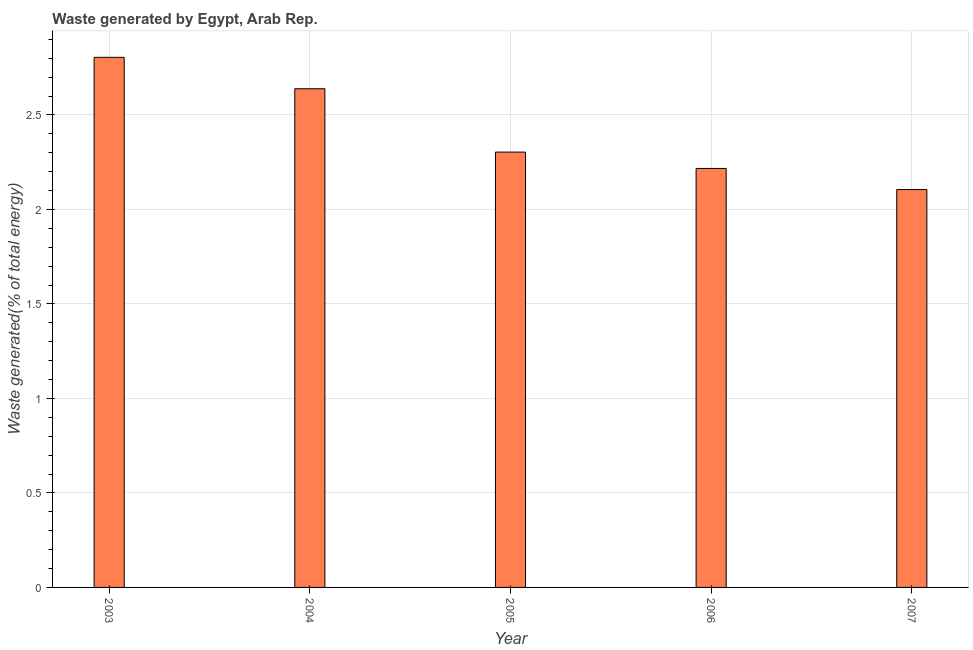Does the graph contain any zero values?
Your answer should be compact. No. Does the graph contain grids?
Provide a short and direct response. Yes. What is the title of the graph?
Provide a short and direct response. Waste generated by Egypt, Arab Rep. What is the label or title of the X-axis?
Make the answer very short. Year. What is the label or title of the Y-axis?
Keep it short and to the point. Waste generated(% of total energy). What is the amount of waste generated in 2004?
Provide a succinct answer. 2.64. Across all years, what is the maximum amount of waste generated?
Give a very brief answer. 2.8. Across all years, what is the minimum amount of waste generated?
Keep it short and to the point. 2.11. In which year was the amount of waste generated maximum?
Make the answer very short. 2003. In which year was the amount of waste generated minimum?
Offer a very short reply. 2007. What is the sum of the amount of waste generated?
Your answer should be very brief. 12.07. What is the difference between the amount of waste generated in 2003 and 2006?
Your answer should be very brief. 0.59. What is the average amount of waste generated per year?
Your answer should be compact. 2.41. What is the median amount of waste generated?
Provide a short and direct response. 2.3. What is the ratio of the amount of waste generated in 2005 to that in 2006?
Ensure brevity in your answer.  1.04. Is the difference between the amount of waste generated in 2003 and 2005 greater than the difference between any two years?
Offer a terse response. No. What is the difference between the highest and the second highest amount of waste generated?
Your answer should be compact. 0.17. Is the sum of the amount of waste generated in 2003 and 2005 greater than the maximum amount of waste generated across all years?
Offer a very short reply. Yes. What is the difference between the highest and the lowest amount of waste generated?
Offer a terse response. 0.7. In how many years, is the amount of waste generated greater than the average amount of waste generated taken over all years?
Make the answer very short. 2. Are all the bars in the graph horizontal?
Keep it short and to the point. No. How many years are there in the graph?
Offer a terse response. 5. What is the difference between two consecutive major ticks on the Y-axis?
Your response must be concise. 0.5. What is the Waste generated(% of total energy) in 2003?
Keep it short and to the point. 2.8. What is the Waste generated(% of total energy) of 2004?
Keep it short and to the point. 2.64. What is the Waste generated(% of total energy) of 2005?
Provide a short and direct response. 2.3. What is the Waste generated(% of total energy) of 2006?
Give a very brief answer. 2.22. What is the Waste generated(% of total energy) of 2007?
Make the answer very short. 2.11. What is the difference between the Waste generated(% of total energy) in 2003 and 2004?
Provide a succinct answer. 0.17. What is the difference between the Waste generated(% of total energy) in 2003 and 2005?
Give a very brief answer. 0.5. What is the difference between the Waste generated(% of total energy) in 2003 and 2006?
Make the answer very short. 0.59. What is the difference between the Waste generated(% of total energy) in 2003 and 2007?
Provide a short and direct response. 0.7. What is the difference between the Waste generated(% of total energy) in 2004 and 2005?
Your answer should be compact. 0.34. What is the difference between the Waste generated(% of total energy) in 2004 and 2006?
Offer a terse response. 0.42. What is the difference between the Waste generated(% of total energy) in 2004 and 2007?
Keep it short and to the point. 0.53. What is the difference between the Waste generated(% of total energy) in 2005 and 2006?
Your answer should be very brief. 0.09. What is the difference between the Waste generated(% of total energy) in 2005 and 2007?
Your answer should be very brief. 0.2. What is the difference between the Waste generated(% of total energy) in 2006 and 2007?
Offer a very short reply. 0.11. What is the ratio of the Waste generated(% of total energy) in 2003 to that in 2004?
Ensure brevity in your answer.  1.06. What is the ratio of the Waste generated(% of total energy) in 2003 to that in 2005?
Provide a succinct answer. 1.22. What is the ratio of the Waste generated(% of total energy) in 2003 to that in 2006?
Provide a succinct answer. 1.26. What is the ratio of the Waste generated(% of total energy) in 2003 to that in 2007?
Ensure brevity in your answer.  1.33. What is the ratio of the Waste generated(% of total energy) in 2004 to that in 2005?
Your answer should be compact. 1.15. What is the ratio of the Waste generated(% of total energy) in 2004 to that in 2006?
Offer a very short reply. 1.19. What is the ratio of the Waste generated(% of total energy) in 2004 to that in 2007?
Ensure brevity in your answer.  1.25. What is the ratio of the Waste generated(% of total energy) in 2005 to that in 2006?
Give a very brief answer. 1.04. What is the ratio of the Waste generated(% of total energy) in 2005 to that in 2007?
Give a very brief answer. 1.09. What is the ratio of the Waste generated(% of total energy) in 2006 to that in 2007?
Keep it short and to the point. 1.05. 